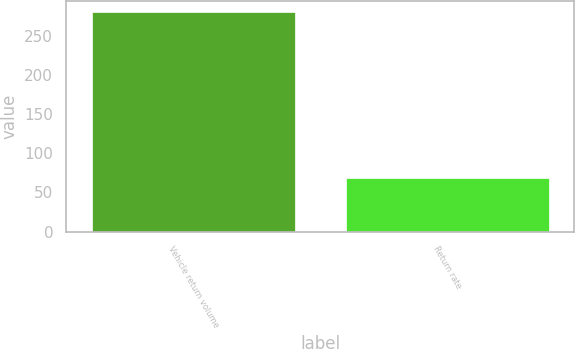<chart> <loc_0><loc_0><loc_500><loc_500><bar_chart><fcel>Vehicle return volume<fcel>Return rate<nl><fcel>281<fcel>69<nl></chart> 